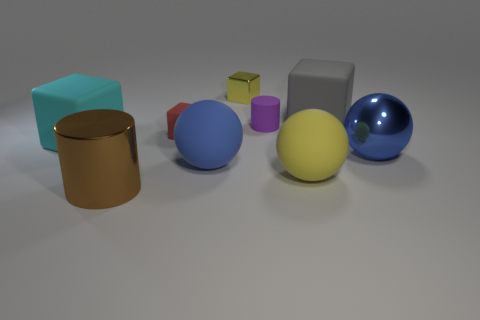Is the color of the small shiny block the same as the large cylinder?
Give a very brief answer. No. What number of objects are either blue balls that are on the right side of the large gray cube or gray matte things?
Give a very brief answer. 2. There is a tiny shiny cube; is its color the same as the big matte ball to the right of the yellow metallic object?
Make the answer very short. Yes. Is there a red cube that has the same size as the rubber cylinder?
Provide a short and direct response. Yes. The thing that is to the left of the thing in front of the large yellow rubber sphere is made of what material?
Ensure brevity in your answer.  Rubber. What number of large matte things have the same color as the metallic ball?
Provide a succinct answer. 1. There is a tiny yellow thing that is the same material as the brown cylinder; what shape is it?
Make the answer very short. Cube. What size is the yellow object in front of the gray matte cube?
Your answer should be very brief. Large. Are there the same number of tiny yellow metal objects behind the large yellow matte sphere and blue matte spheres in front of the large brown thing?
Offer a terse response. No. There is a shiny object on the right side of the yellow object behind the large matte cube that is left of the large metal cylinder; what color is it?
Provide a short and direct response. Blue. 